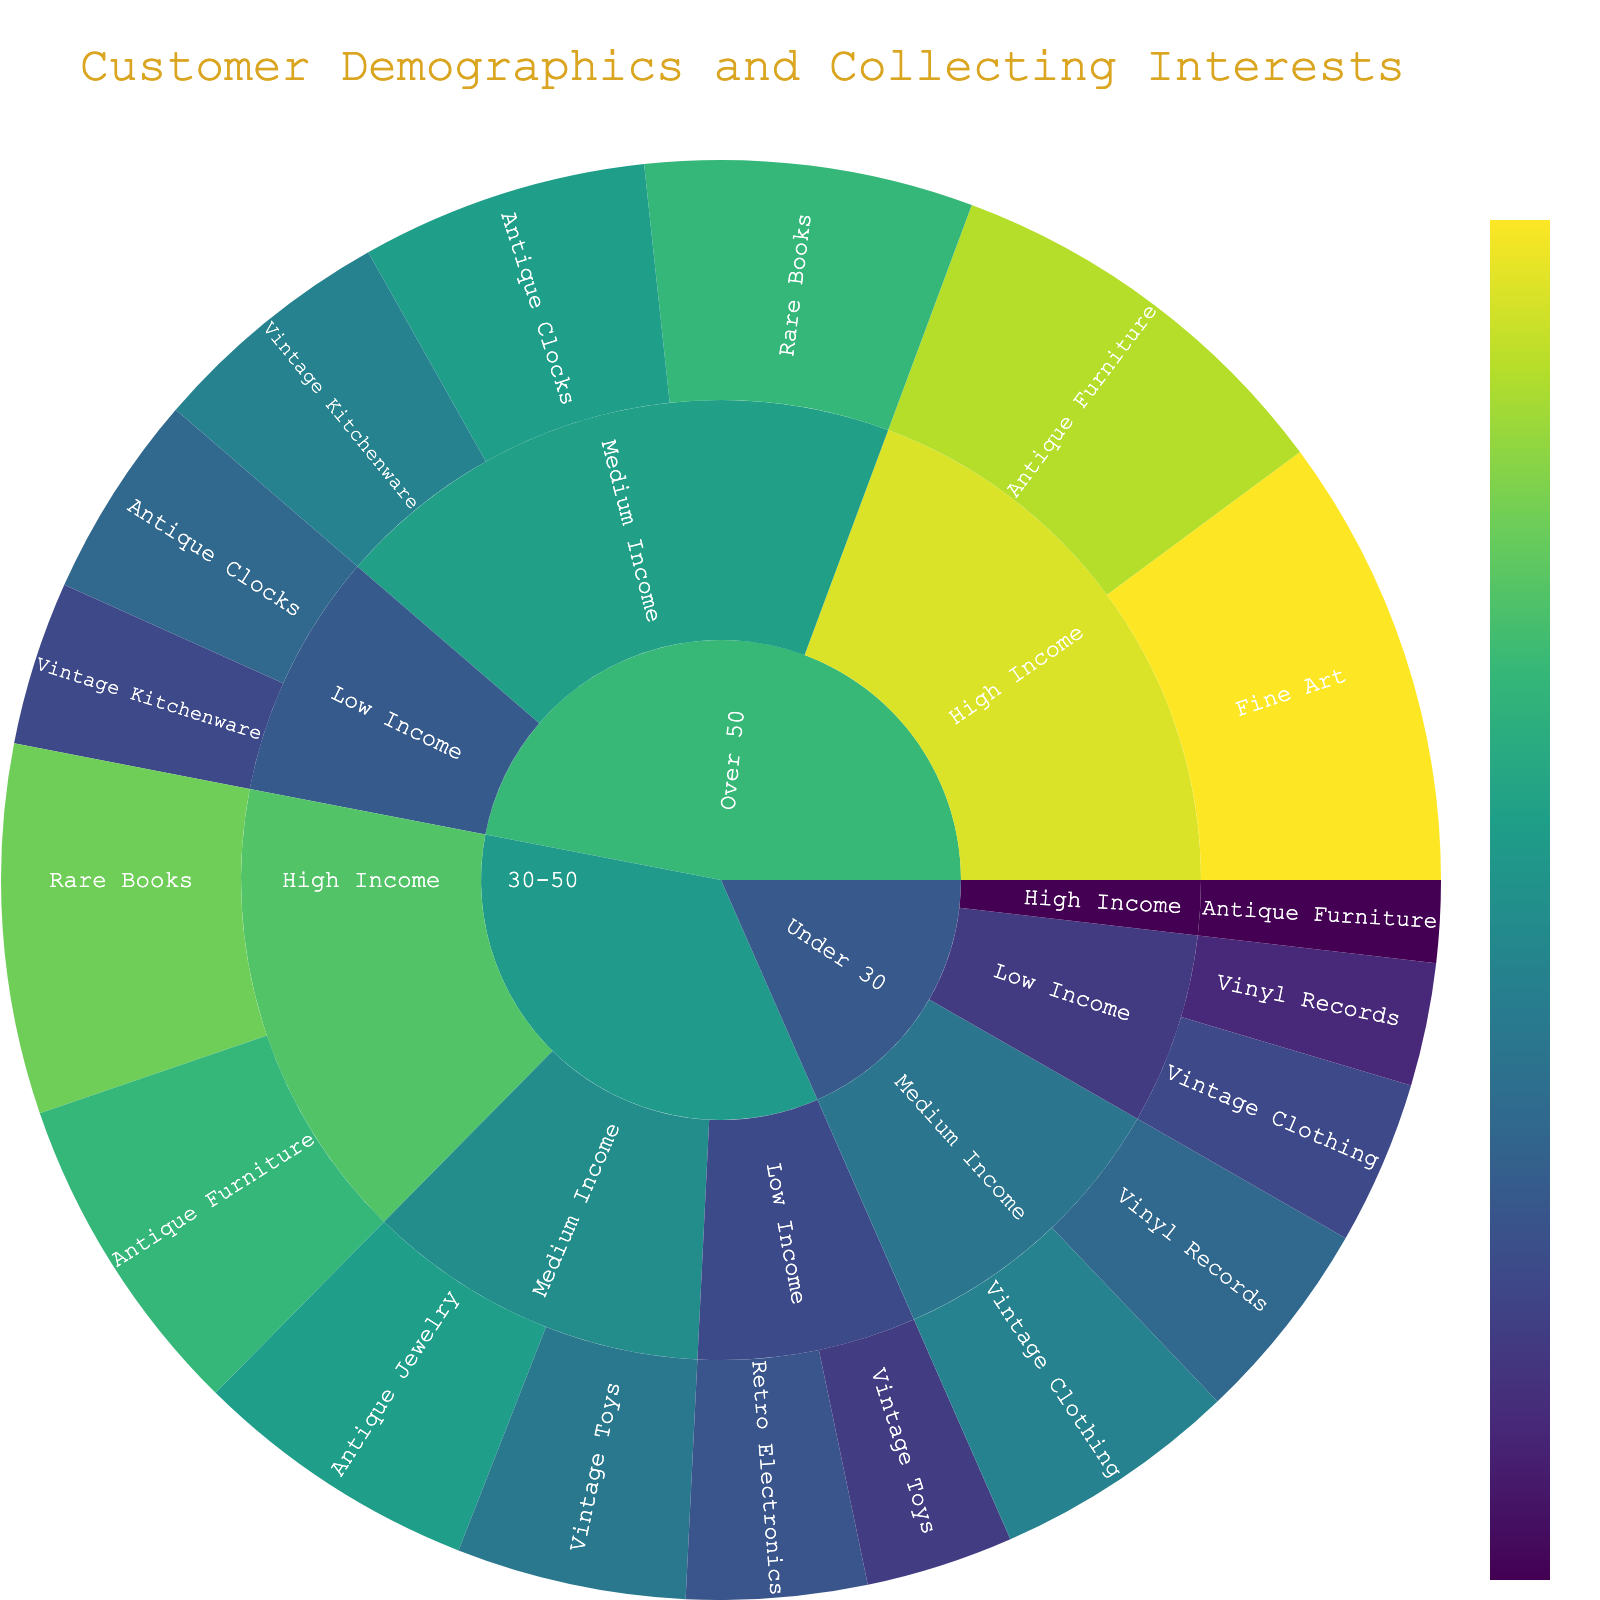What is the title of the plot? The title of a plot usually appears at the top of the figure. By looking at the figure, we can read the text that indicates the title.
Answer: Customer Demographics and Collecting Interests Which age group has the highest value for High Income Vinyl Records? By observing the hierarchy in the sunburst plot and locating the segment for Vinyl Records under High Income, we can see that the Under 30 age group is represented there.
Answer: Under 30 How many value points are represented for the 30-50 age group in medium income level? Navigate to the 30-50 age group section and look at the branches extending to the medium income level. Count each distinct value point associated with different collecting interests.
Answer: 2 Which age group has the most varied collecting interests in the high income bracket? By examining the segment for High Income in each age group, we look for the one with the highest number of unique sections (collecting interests). The 30-50 age group has the most varied interests.
Answer: 30-50 What is the combined value for Antique Clocks in the Medium Income level across all age groups? Locate all Medium Income segments for different age groups and sum the values associated with Antique Clocks. The values are from Over 50 (35+0=35).
Answer: 35 Does the Over 50 age group in high income bracket have higher values for collecting interests compared to Under 30 in high income? Observe the segments for High Income under Over 50 and Under 30, and compare the values for the collecting interests. Over 50 has significantly higher values and variations.
Answer: Yes Which collecting interest has the highest value in the medium income level for the Over 50 age group? Navigate to the Over 50 age group and within that, check the Medium Income sub-section; observe the values of the collecting interests listed and identify the highest one.
Answer: Rare Books What is the total value of collecting interests in the low income bracket across all age groups? Sum up all values from the Low Income sections under each age group (15 + 20 + 18 + 22 + 20 + 25 = 120).
Answer: 120 Which age group and income level combination has the lowest value for any collecting interest, and what is that value? By examining each segment in the sunburst plot and looking for the lowest recorded value within any collecting interest (found in Under 30, High Income, Antique Furniture: 10).
Answer: Under 30 and High Income with 10 